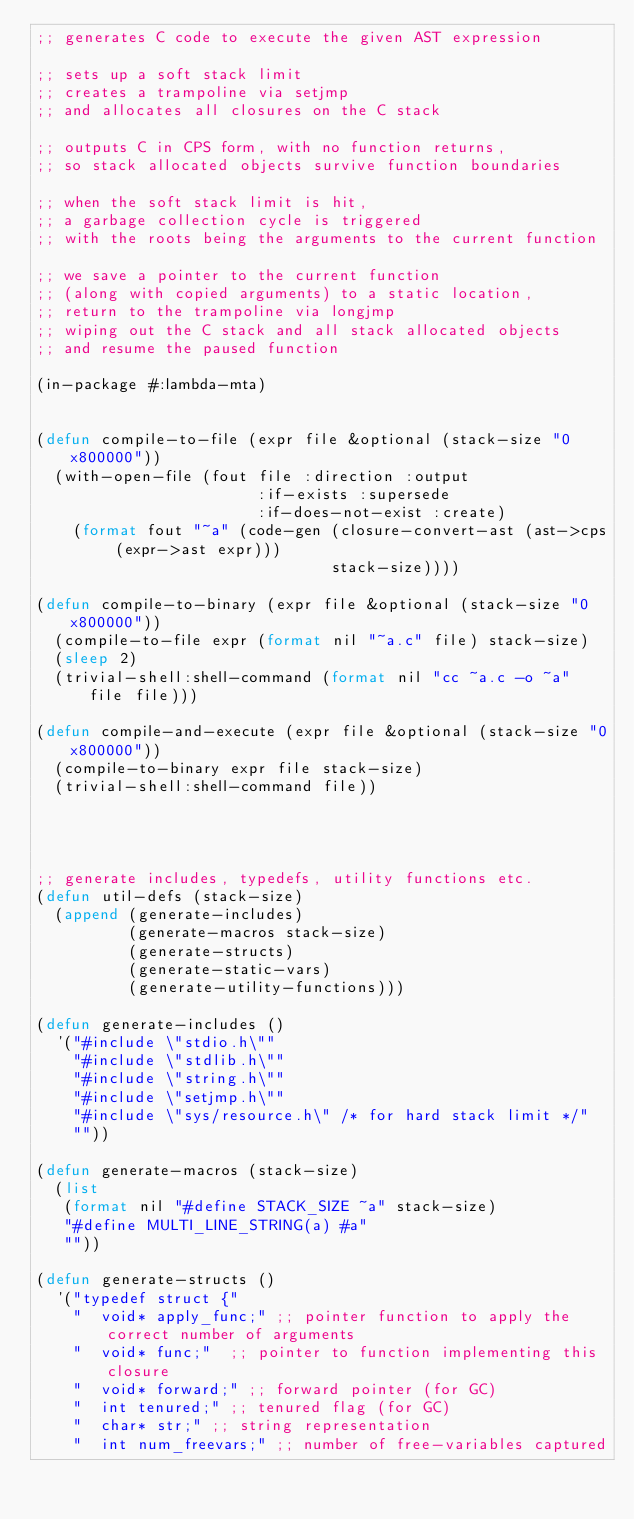<code> <loc_0><loc_0><loc_500><loc_500><_Lisp_>;; generates C code to execute the given AST expression

;; sets up a soft stack limit
;; creates a trampoline via setjmp
;; and allocates all closures on the C stack

;; outputs C in CPS form, with no function returns,
;; so stack allocated objects survive function boundaries

;; when the soft stack limit is hit,
;; a garbage collection cycle is triggered
;; with the roots being the arguments to the current function

;; we save a pointer to the current function
;; (along with copied arguments) to a static location,
;; return to the trampoline via longjmp
;; wiping out the C stack and all stack allocated objects
;; and resume the paused function

(in-package #:lambda-mta)


(defun compile-to-file (expr file &optional (stack-size "0x800000"))
  (with-open-file (fout file :direction :output
                        :if-exists :supersede
                        :if-does-not-exist :create)
    (format fout "~a" (code-gen (closure-convert-ast (ast->cps (expr->ast expr)))
                                stack-size))))

(defun compile-to-binary (expr file &optional (stack-size "0x800000"))
  (compile-to-file expr (format nil "~a.c" file) stack-size)
  (sleep 2)
  (trivial-shell:shell-command (format nil "cc ~a.c -o ~a" file file)))

(defun compile-and-execute (expr file &optional (stack-size "0x800000"))
  (compile-to-binary expr file stack-size)
  (trivial-shell:shell-command file))




;; generate includes, typedefs, utility functions etc.
(defun util-defs (stack-size)
  (append (generate-includes)
          (generate-macros stack-size)
          (generate-structs)
          (generate-static-vars)
          (generate-utility-functions)))

(defun generate-includes ()
  '("#include \"stdio.h\""
    "#include \"stdlib.h\""
    "#include \"string.h\""
    "#include \"setjmp.h\""
    "#include \"sys/resource.h\" /* for hard stack limit */"
    ""))

(defun generate-macros (stack-size)
  (list
   (format nil "#define STACK_SIZE ~a" stack-size)
   "#define MULTI_LINE_STRING(a) #a"
   ""))

(defun generate-structs ()
  '("typedef struct {"
    "  void* apply_func;" ;; pointer function to apply the correct number of arguments
    "  void* func;"  ;; pointer to function implementing this closure
    "  void* forward;" ;; forward pointer (for GC)
    "  int tenured;" ;; tenured flag (for GC)
    "  char* str;" ;; string representation
    "  int num_freevars;" ;; number of free-variables captured</code> 